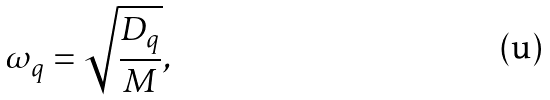Convert formula to latex. <formula><loc_0><loc_0><loc_500><loc_500>\omega _ { q } = \sqrt { \frac { D _ { q } } { M } } ,</formula> 